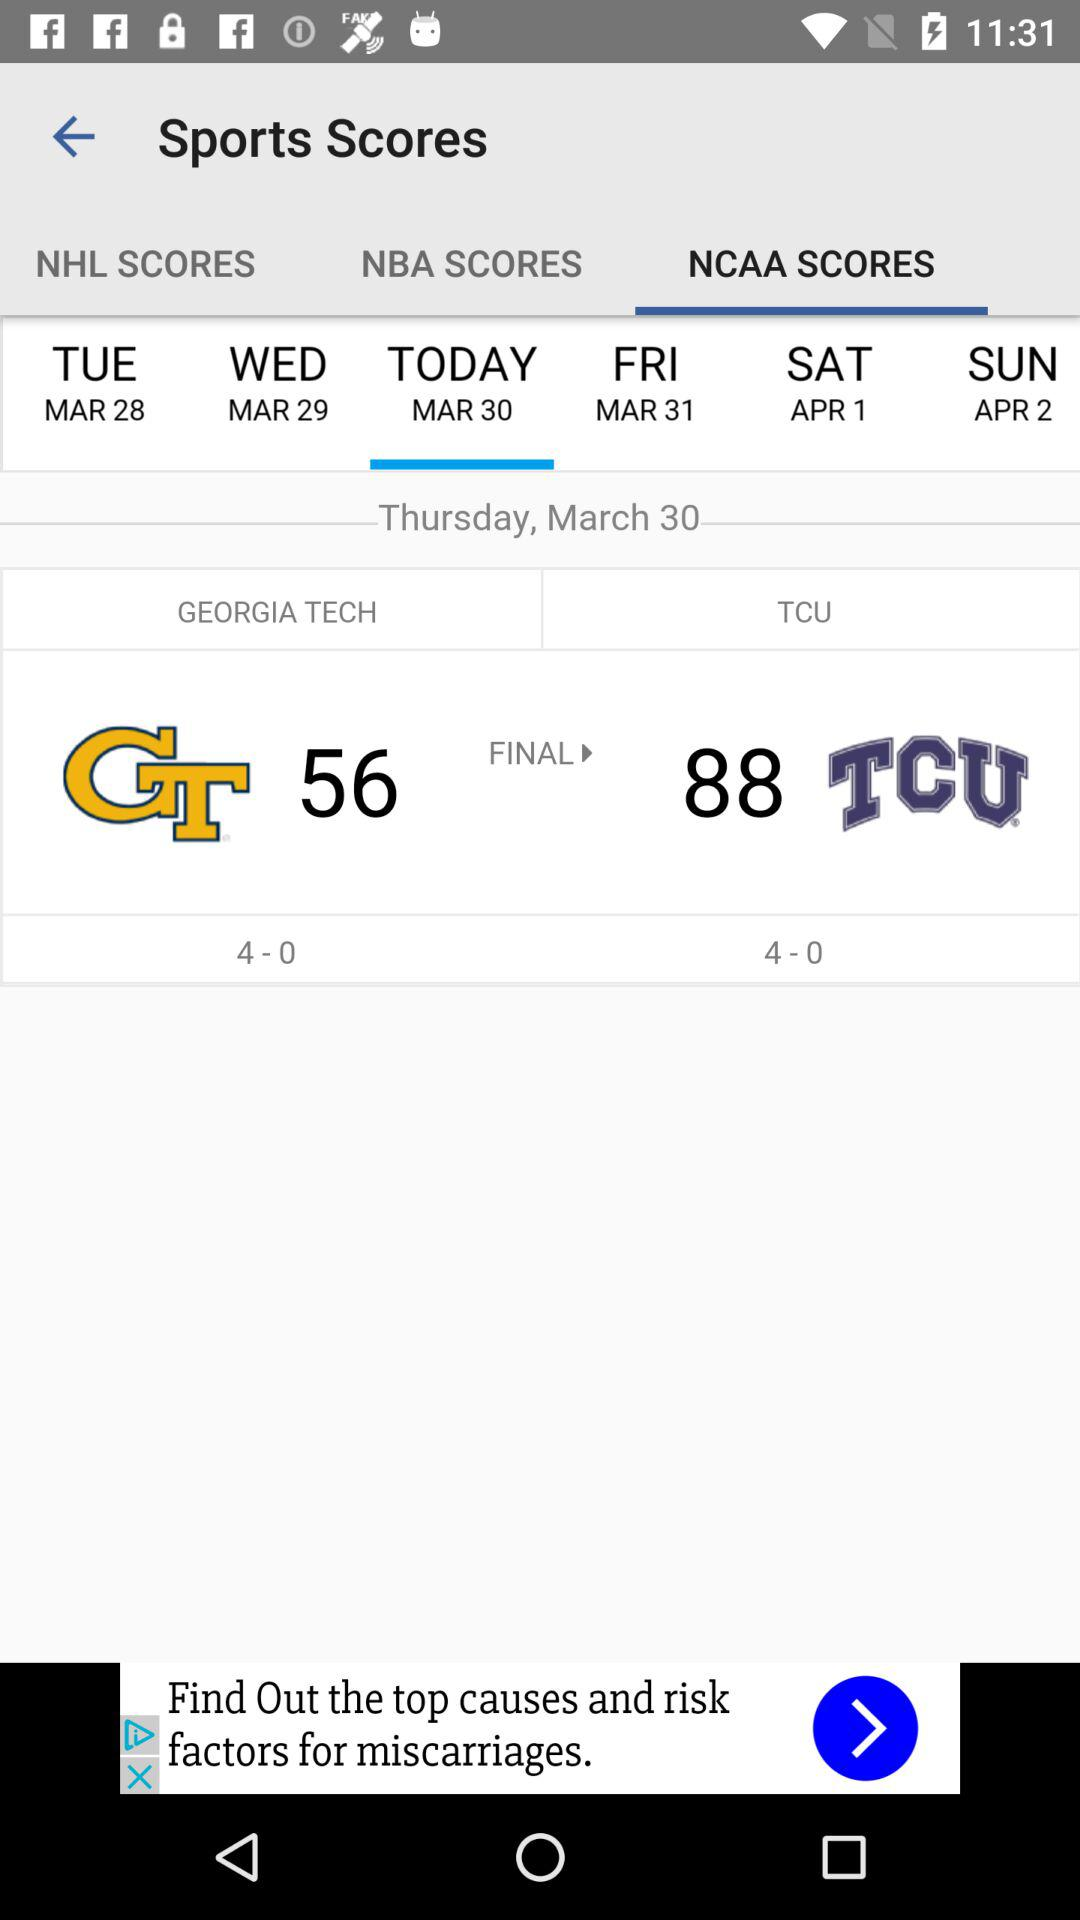How many scores are there for "TCU"? There are 88 scores. 